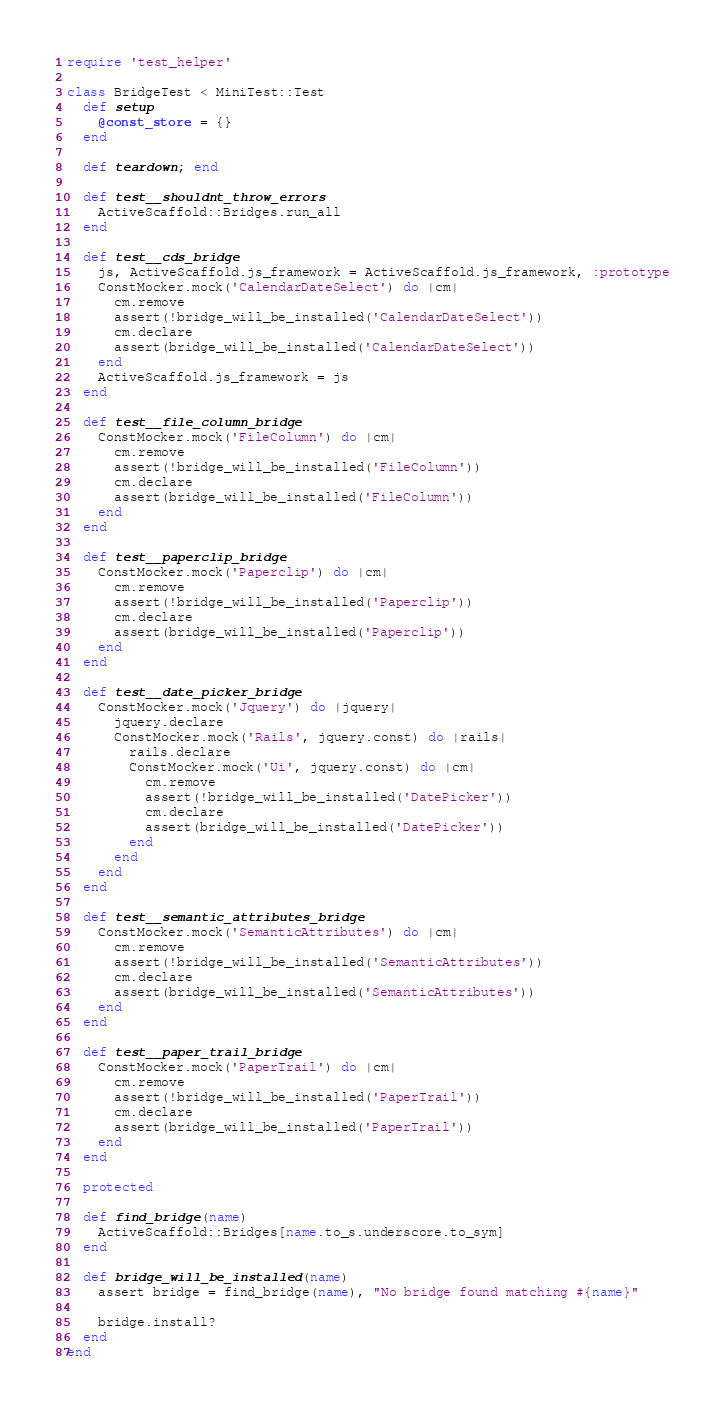Convert code to text. <code><loc_0><loc_0><loc_500><loc_500><_Ruby_>require 'test_helper'

class BridgeTest < MiniTest::Test
  def setup
    @const_store = {}
  end

  def teardown; end

  def test__shouldnt_throw_errors
    ActiveScaffold::Bridges.run_all
  end

  def test__cds_bridge
    js, ActiveScaffold.js_framework = ActiveScaffold.js_framework, :prototype
    ConstMocker.mock('CalendarDateSelect') do |cm|
      cm.remove
      assert(!bridge_will_be_installed('CalendarDateSelect'))
      cm.declare
      assert(bridge_will_be_installed('CalendarDateSelect'))
    end
    ActiveScaffold.js_framework = js
  end

  def test__file_column_bridge
    ConstMocker.mock('FileColumn') do |cm|
      cm.remove
      assert(!bridge_will_be_installed('FileColumn'))
      cm.declare
      assert(bridge_will_be_installed('FileColumn'))
    end
  end

  def test__paperclip_bridge
    ConstMocker.mock('Paperclip') do |cm|
      cm.remove
      assert(!bridge_will_be_installed('Paperclip'))
      cm.declare
      assert(bridge_will_be_installed('Paperclip'))
    end
  end

  def test__date_picker_bridge
    ConstMocker.mock('Jquery') do |jquery|
      jquery.declare
      ConstMocker.mock('Rails', jquery.const) do |rails|
        rails.declare
        ConstMocker.mock('Ui', jquery.const) do |cm|
          cm.remove
          assert(!bridge_will_be_installed('DatePicker'))
          cm.declare
          assert(bridge_will_be_installed('DatePicker'))
        end
      end
    end
  end

  def test__semantic_attributes_bridge
    ConstMocker.mock('SemanticAttributes') do |cm|
      cm.remove
      assert(!bridge_will_be_installed('SemanticAttributes'))
      cm.declare
      assert(bridge_will_be_installed('SemanticAttributes'))
    end
  end

  def test__paper_trail_bridge
    ConstMocker.mock('PaperTrail') do |cm|
      cm.remove
      assert(!bridge_will_be_installed('PaperTrail'))
      cm.declare
      assert(bridge_will_be_installed('PaperTrail'))
    end
  end

  protected

  def find_bridge(name)
    ActiveScaffold::Bridges[name.to_s.underscore.to_sym]
  end

  def bridge_will_be_installed(name)
    assert bridge = find_bridge(name), "No bridge found matching #{name}"

    bridge.install?
  end
end
</code> 